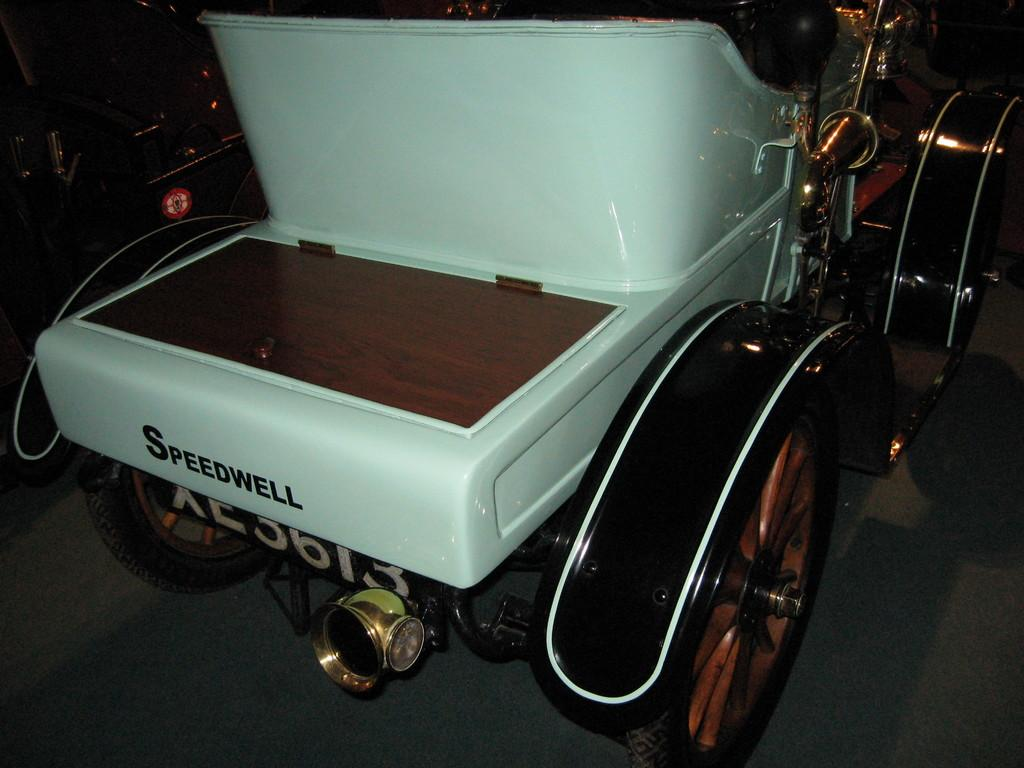What is the main subject of the image? The main subject of the image is a car. Can you describe the position of the car in the image? The car is placed on a surface. What type of rod can be seen holding up the cherry tree in the image? There is no rod or cherry tree present in the image; it features a car placed on a surface. Can you tell me how many grandfathers are visible in the image? There are no grandfathers present in the image. 